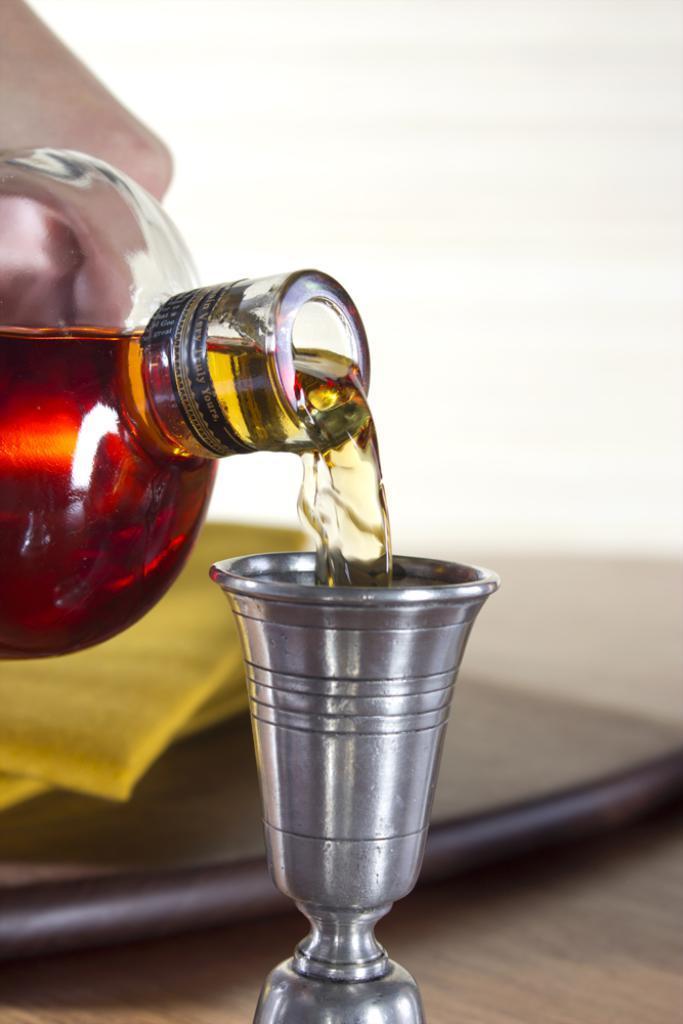How would you summarize this image in a sentence or two? Here a person is pouring wine into a glass which is on the table. We can also see a plate on the table. 